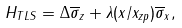<formula> <loc_0><loc_0><loc_500><loc_500>H _ { T L S } = \Delta \overline { \sigma } _ { z } + \lambda ( x / x _ { z p } ) \overline { \sigma } _ { x } ,</formula> 